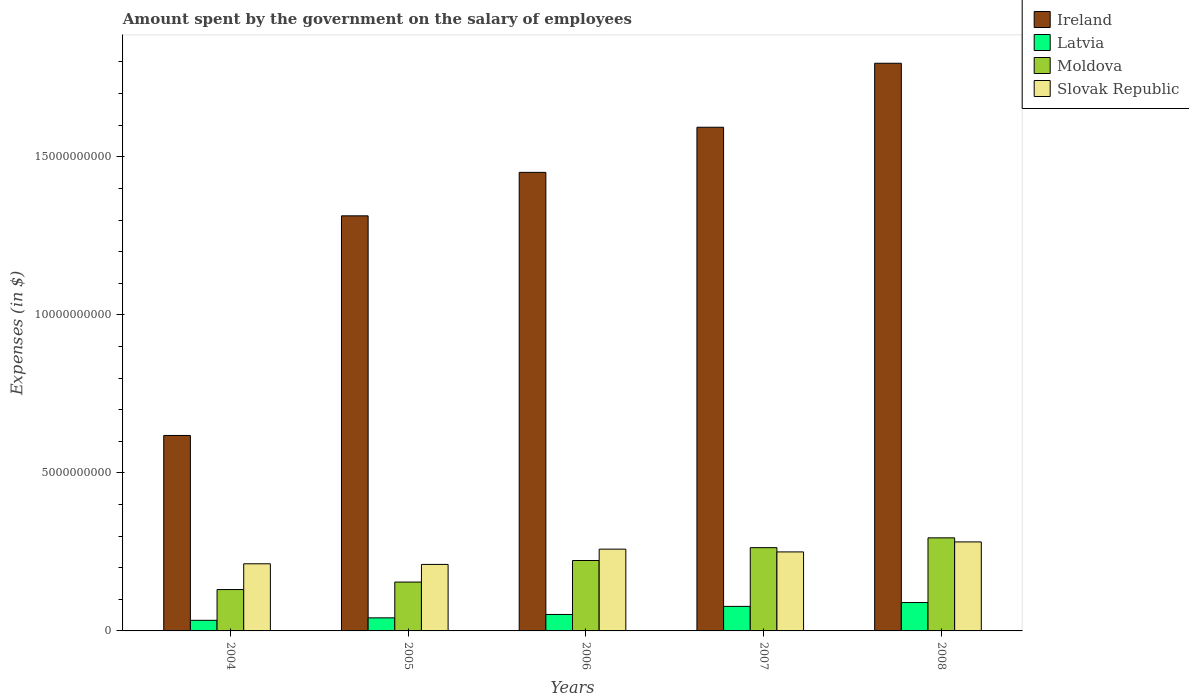How many different coloured bars are there?
Offer a very short reply. 4. How many groups of bars are there?
Your answer should be compact. 5. Are the number of bars per tick equal to the number of legend labels?
Ensure brevity in your answer.  Yes. How many bars are there on the 5th tick from the right?
Your response must be concise. 4. What is the amount spent on the salary of employees by the government in Slovak Republic in 2005?
Ensure brevity in your answer.  2.10e+09. Across all years, what is the maximum amount spent on the salary of employees by the government in Moldova?
Keep it short and to the point. 2.94e+09. Across all years, what is the minimum amount spent on the salary of employees by the government in Ireland?
Offer a terse response. 6.18e+09. In which year was the amount spent on the salary of employees by the government in Slovak Republic maximum?
Give a very brief answer. 2008. What is the total amount spent on the salary of employees by the government in Moldova in the graph?
Your answer should be very brief. 1.07e+1. What is the difference between the amount spent on the salary of employees by the government in Latvia in 2004 and that in 2008?
Ensure brevity in your answer.  -5.63e+08. What is the difference between the amount spent on the salary of employees by the government in Ireland in 2005 and the amount spent on the salary of employees by the government in Slovak Republic in 2006?
Make the answer very short. 1.05e+1. What is the average amount spent on the salary of employees by the government in Latvia per year?
Provide a short and direct response. 5.89e+08. In the year 2006, what is the difference between the amount spent on the salary of employees by the government in Latvia and amount spent on the salary of employees by the government in Ireland?
Offer a terse response. -1.40e+1. What is the ratio of the amount spent on the salary of employees by the government in Latvia in 2005 to that in 2007?
Make the answer very short. 0.53. Is the amount spent on the salary of employees by the government in Moldova in 2005 less than that in 2006?
Keep it short and to the point. Yes. Is the difference between the amount spent on the salary of employees by the government in Latvia in 2005 and 2007 greater than the difference between the amount spent on the salary of employees by the government in Ireland in 2005 and 2007?
Keep it short and to the point. Yes. What is the difference between the highest and the second highest amount spent on the salary of employees by the government in Ireland?
Give a very brief answer. 2.02e+09. What is the difference between the highest and the lowest amount spent on the salary of employees by the government in Slovak Republic?
Your answer should be compact. 7.11e+08. Is the sum of the amount spent on the salary of employees by the government in Slovak Republic in 2004 and 2005 greater than the maximum amount spent on the salary of employees by the government in Ireland across all years?
Provide a short and direct response. No. Is it the case that in every year, the sum of the amount spent on the salary of employees by the government in Latvia and amount spent on the salary of employees by the government in Moldova is greater than the sum of amount spent on the salary of employees by the government in Slovak Republic and amount spent on the salary of employees by the government in Ireland?
Provide a succinct answer. No. What does the 4th bar from the left in 2007 represents?
Ensure brevity in your answer.  Slovak Republic. What does the 1st bar from the right in 2004 represents?
Make the answer very short. Slovak Republic. Are all the bars in the graph horizontal?
Keep it short and to the point. No. Are the values on the major ticks of Y-axis written in scientific E-notation?
Provide a short and direct response. No. Does the graph contain grids?
Offer a very short reply. No. How many legend labels are there?
Offer a terse response. 4. What is the title of the graph?
Make the answer very short. Amount spent by the government on the salary of employees. What is the label or title of the Y-axis?
Provide a succinct answer. Expenses (in $). What is the Expenses (in $) in Ireland in 2004?
Provide a succinct answer. 6.18e+09. What is the Expenses (in $) in Latvia in 2004?
Make the answer very short. 3.35e+08. What is the Expenses (in $) in Moldova in 2004?
Ensure brevity in your answer.  1.31e+09. What is the Expenses (in $) in Slovak Republic in 2004?
Offer a very short reply. 2.12e+09. What is the Expenses (in $) of Ireland in 2005?
Your answer should be very brief. 1.31e+1. What is the Expenses (in $) in Latvia in 2005?
Offer a very short reply. 4.13e+08. What is the Expenses (in $) in Moldova in 2005?
Provide a short and direct response. 1.55e+09. What is the Expenses (in $) in Slovak Republic in 2005?
Provide a short and direct response. 2.10e+09. What is the Expenses (in $) in Ireland in 2006?
Offer a very short reply. 1.45e+1. What is the Expenses (in $) of Latvia in 2006?
Give a very brief answer. 5.21e+08. What is the Expenses (in $) of Moldova in 2006?
Your response must be concise. 2.23e+09. What is the Expenses (in $) of Slovak Republic in 2006?
Provide a short and direct response. 2.59e+09. What is the Expenses (in $) in Ireland in 2007?
Offer a terse response. 1.59e+1. What is the Expenses (in $) in Latvia in 2007?
Your response must be concise. 7.76e+08. What is the Expenses (in $) in Moldova in 2007?
Offer a terse response. 2.63e+09. What is the Expenses (in $) in Slovak Republic in 2007?
Keep it short and to the point. 2.50e+09. What is the Expenses (in $) in Ireland in 2008?
Ensure brevity in your answer.  1.80e+1. What is the Expenses (in $) in Latvia in 2008?
Offer a very short reply. 8.98e+08. What is the Expenses (in $) of Moldova in 2008?
Keep it short and to the point. 2.94e+09. What is the Expenses (in $) in Slovak Republic in 2008?
Your answer should be very brief. 2.82e+09. Across all years, what is the maximum Expenses (in $) in Ireland?
Your answer should be very brief. 1.80e+1. Across all years, what is the maximum Expenses (in $) in Latvia?
Your answer should be very brief. 8.98e+08. Across all years, what is the maximum Expenses (in $) of Moldova?
Offer a very short reply. 2.94e+09. Across all years, what is the maximum Expenses (in $) in Slovak Republic?
Your answer should be compact. 2.82e+09. Across all years, what is the minimum Expenses (in $) of Ireland?
Offer a very short reply. 6.18e+09. Across all years, what is the minimum Expenses (in $) in Latvia?
Ensure brevity in your answer.  3.35e+08. Across all years, what is the minimum Expenses (in $) in Moldova?
Give a very brief answer. 1.31e+09. Across all years, what is the minimum Expenses (in $) of Slovak Republic?
Keep it short and to the point. 2.10e+09. What is the total Expenses (in $) in Ireland in the graph?
Offer a very short reply. 6.77e+1. What is the total Expenses (in $) in Latvia in the graph?
Your response must be concise. 2.94e+09. What is the total Expenses (in $) of Moldova in the graph?
Offer a very short reply. 1.07e+1. What is the total Expenses (in $) of Slovak Republic in the graph?
Offer a terse response. 1.21e+1. What is the difference between the Expenses (in $) of Ireland in 2004 and that in 2005?
Offer a terse response. -6.95e+09. What is the difference between the Expenses (in $) in Latvia in 2004 and that in 2005?
Offer a very short reply. -7.79e+07. What is the difference between the Expenses (in $) of Moldova in 2004 and that in 2005?
Make the answer very short. -2.37e+08. What is the difference between the Expenses (in $) in Slovak Republic in 2004 and that in 2005?
Ensure brevity in your answer.  1.95e+07. What is the difference between the Expenses (in $) of Ireland in 2004 and that in 2006?
Provide a succinct answer. -8.32e+09. What is the difference between the Expenses (in $) in Latvia in 2004 and that in 2006?
Provide a short and direct response. -1.86e+08. What is the difference between the Expenses (in $) of Moldova in 2004 and that in 2006?
Keep it short and to the point. -9.19e+08. What is the difference between the Expenses (in $) of Slovak Republic in 2004 and that in 2006?
Ensure brevity in your answer.  -4.64e+08. What is the difference between the Expenses (in $) in Ireland in 2004 and that in 2007?
Offer a terse response. -9.75e+09. What is the difference between the Expenses (in $) of Latvia in 2004 and that in 2007?
Provide a succinct answer. -4.41e+08. What is the difference between the Expenses (in $) in Moldova in 2004 and that in 2007?
Make the answer very short. -1.33e+09. What is the difference between the Expenses (in $) of Slovak Republic in 2004 and that in 2007?
Make the answer very short. -3.76e+08. What is the difference between the Expenses (in $) of Ireland in 2004 and that in 2008?
Keep it short and to the point. -1.18e+1. What is the difference between the Expenses (in $) in Latvia in 2004 and that in 2008?
Offer a terse response. -5.63e+08. What is the difference between the Expenses (in $) in Moldova in 2004 and that in 2008?
Make the answer very short. -1.64e+09. What is the difference between the Expenses (in $) of Slovak Republic in 2004 and that in 2008?
Give a very brief answer. -6.92e+08. What is the difference between the Expenses (in $) in Ireland in 2005 and that in 2006?
Provide a short and direct response. -1.38e+09. What is the difference between the Expenses (in $) of Latvia in 2005 and that in 2006?
Your answer should be compact. -1.08e+08. What is the difference between the Expenses (in $) of Moldova in 2005 and that in 2006?
Your response must be concise. -6.82e+08. What is the difference between the Expenses (in $) in Slovak Republic in 2005 and that in 2006?
Ensure brevity in your answer.  -4.83e+08. What is the difference between the Expenses (in $) in Ireland in 2005 and that in 2007?
Your response must be concise. -2.80e+09. What is the difference between the Expenses (in $) in Latvia in 2005 and that in 2007?
Make the answer very short. -3.63e+08. What is the difference between the Expenses (in $) in Moldova in 2005 and that in 2007?
Offer a terse response. -1.09e+09. What is the difference between the Expenses (in $) of Slovak Republic in 2005 and that in 2007?
Give a very brief answer. -3.95e+08. What is the difference between the Expenses (in $) in Ireland in 2005 and that in 2008?
Provide a short and direct response. -4.83e+09. What is the difference between the Expenses (in $) of Latvia in 2005 and that in 2008?
Your answer should be compact. -4.85e+08. What is the difference between the Expenses (in $) in Moldova in 2005 and that in 2008?
Your answer should be compact. -1.40e+09. What is the difference between the Expenses (in $) of Slovak Republic in 2005 and that in 2008?
Your response must be concise. -7.11e+08. What is the difference between the Expenses (in $) in Ireland in 2006 and that in 2007?
Your answer should be very brief. -1.43e+09. What is the difference between the Expenses (in $) in Latvia in 2006 and that in 2007?
Give a very brief answer. -2.56e+08. What is the difference between the Expenses (in $) of Moldova in 2006 and that in 2007?
Your response must be concise. -4.07e+08. What is the difference between the Expenses (in $) in Slovak Republic in 2006 and that in 2007?
Your response must be concise. 8.77e+07. What is the difference between the Expenses (in $) in Ireland in 2006 and that in 2008?
Provide a succinct answer. -3.45e+09. What is the difference between the Expenses (in $) of Latvia in 2006 and that in 2008?
Your response must be concise. -3.77e+08. What is the difference between the Expenses (in $) of Moldova in 2006 and that in 2008?
Keep it short and to the point. -7.17e+08. What is the difference between the Expenses (in $) of Slovak Republic in 2006 and that in 2008?
Provide a short and direct response. -2.28e+08. What is the difference between the Expenses (in $) in Ireland in 2007 and that in 2008?
Keep it short and to the point. -2.02e+09. What is the difference between the Expenses (in $) in Latvia in 2007 and that in 2008?
Offer a terse response. -1.22e+08. What is the difference between the Expenses (in $) in Moldova in 2007 and that in 2008?
Your answer should be compact. -3.10e+08. What is the difference between the Expenses (in $) in Slovak Republic in 2007 and that in 2008?
Provide a short and direct response. -3.16e+08. What is the difference between the Expenses (in $) of Ireland in 2004 and the Expenses (in $) of Latvia in 2005?
Keep it short and to the point. 5.77e+09. What is the difference between the Expenses (in $) in Ireland in 2004 and the Expenses (in $) in Moldova in 2005?
Your response must be concise. 4.64e+09. What is the difference between the Expenses (in $) of Ireland in 2004 and the Expenses (in $) of Slovak Republic in 2005?
Offer a terse response. 4.08e+09. What is the difference between the Expenses (in $) in Latvia in 2004 and the Expenses (in $) in Moldova in 2005?
Ensure brevity in your answer.  -1.21e+09. What is the difference between the Expenses (in $) of Latvia in 2004 and the Expenses (in $) of Slovak Republic in 2005?
Ensure brevity in your answer.  -1.77e+09. What is the difference between the Expenses (in $) of Moldova in 2004 and the Expenses (in $) of Slovak Republic in 2005?
Make the answer very short. -7.95e+08. What is the difference between the Expenses (in $) of Ireland in 2004 and the Expenses (in $) of Latvia in 2006?
Ensure brevity in your answer.  5.66e+09. What is the difference between the Expenses (in $) of Ireland in 2004 and the Expenses (in $) of Moldova in 2006?
Your answer should be compact. 3.96e+09. What is the difference between the Expenses (in $) of Ireland in 2004 and the Expenses (in $) of Slovak Republic in 2006?
Your response must be concise. 3.60e+09. What is the difference between the Expenses (in $) of Latvia in 2004 and the Expenses (in $) of Moldova in 2006?
Offer a very short reply. -1.89e+09. What is the difference between the Expenses (in $) in Latvia in 2004 and the Expenses (in $) in Slovak Republic in 2006?
Provide a short and direct response. -2.25e+09. What is the difference between the Expenses (in $) of Moldova in 2004 and the Expenses (in $) of Slovak Republic in 2006?
Give a very brief answer. -1.28e+09. What is the difference between the Expenses (in $) in Ireland in 2004 and the Expenses (in $) in Latvia in 2007?
Offer a terse response. 5.41e+09. What is the difference between the Expenses (in $) in Ireland in 2004 and the Expenses (in $) in Moldova in 2007?
Offer a terse response. 3.55e+09. What is the difference between the Expenses (in $) in Ireland in 2004 and the Expenses (in $) in Slovak Republic in 2007?
Offer a terse response. 3.68e+09. What is the difference between the Expenses (in $) of Latvia in 2004 and the Expenses (in $) of Moldova in 2007?
Provide a succinct answer. -2.30e+09. What is the difference between the Expenses (in $) of Latvia in 2004 and the Expenses (in $) of Slovak Republic in 2007?
Your response must be concise. -2.16e+09. What is the difference between the Expenses (in $) of Moldova in 2004 and the Expenses (in $) of Slovak Republic in 2007?
Give a very brief answer. -1.19e+09. What is the difference between the Expenses (in $) in Ireland in 2004 and the Expenses (in $) in Latvia in 2008?
Provide a short and direct response. 5.29e+09. What is the difference between the Expenses (in $) of Ireland in 2004 and the Expenses (in $) of Moldova in 2008?
Give a very brief answer. 3.24e+09. What is the difference between the Expenses (in $) in Ireland in 2004 and the Expenses (in $) in Slovak Republic in 2008?
Your response must be concise. 3.37e+09. What is the difference between the Expenses (in $) of Latvia in 2004 and the Expenses (in $) of Moldova in 2008?
Provide a short and direct response. -2.61e+09. What is the difference between the Expenses (in $) of Latvia in 2004 and the Expenses (in $) of Slovak Republic in 2008?
Give a very brief answer. -2.48e+09. What is the difference between the Expenses (in $) of Moldova in 2004 and the Expenses (in $) of Slovak Republic in 2008?
Ensure brevity in your answer.  -1.51e+09. What is the difference between the Expenses (in $) of Ireland in 2005 and the Expenses (in $) of Latvia in 2006?
Your answer should be very brief. 1.26e+1. What is the difference between the Expenses (in $) in Ireland in 2005 and the Expenses (in $) in Moldova in 2006?
Offer a terse response. 1.09e+1. What is the difference between the Expenses (in $) in Ireland in 2005 and the Expenses (in $) in Slovak Republic in 2006?
Ensure brevity in your answer.  1.05e+1. What is the difference between the Expenses (in $) in Latvia in 2005 and the Expenses (in $) in Moldova in 2006?
Ensure brevity in your answer.  -1.81e+09. What is the difference between the Expenses (in $) of Latvia in 2005 and the Expenses (in $) of Slovak Republic in 2006?
Your answer should be very brief. -2.17e+09. What is the difference between the Expenses (in $) in Moldova in 2005 and the Expenses (in $) in Slovak Republic in 2006?
Ensure brevity in your answer.  -1.04e+09. What is the difference between the Expenses (in $) in Ireland in 2005 and the Expenses (in $) in Latvia in 2007?
Your answer should be very brief. 1.24e+1. What is the difference between the Expenses (in $) of Ireland in 2005 and the Expenses (in $) of Moldova in 2007?
Your answer should be very brief. 1.05e+1. What is the difference between the Expenses (in $) in Ireland in 2005 and the Expenses (in $) in Slovak Republic in 2007?
Ensure brevity in your answer.  1.06e+1. What is the difference between the Expenses (in $) in Latvia in 2005 and the Expenses (in $) in Moldova in 2007?
Make the answer very short. -2.22e+09. What is the difference between the Expenses (in $) of Latvia in 2005 and the Expenses (in $) of Slovak Republic in 2007?
Your answer should be compact. -2.09e+09. What is the difference between the Expenses (in $) in Moldova in 2005 and the Expenses (in $) in Slovak Republic in 2007?
Ensure brevity in your answer.  -9.54e+08. What is the difference between the Expenses (in $) of Ireland in 2005 and the Expenses (in $) of Latvia in 2008?
Your answer should be compact. 1.22e+1. What is the difference between the Expenses (in $) of Ireland in 2005 and the Expenses (in $) of Moldova in 2008?
Offer a very short reply. 1.02e+1. What is the difference between the Expenses (in $) of Ireland in 2005 and the Expenses (in $) of Slovak Republic in 2008?
Keep it short and to the point. 1.03e+1. What is the difference between the Expenses (in $) in Latvia in 2005 and the Expenses (in $) in Moldova in 2008?
Make the answer very short. -2.53e+09. What is the difference between the Expenses (in $) of Latvia in 2005 and the Expenses (in $) of Slovak Republic in 2008?
Your answer should be very brief. -2.40e+09. What is the difference between the Expenses (in $) of Moldova in 2005 and the Expenses (in $) of Slovak Republic in 2008?
Your answer should be compact. -1.27e+09. What is the difference between the Expenses (in $) in Ireland in 2006 and the Expenses (in $) in Latvia in 2007?
Your answer should be compact. 1.37e+1. What is the difference between the Expenses (in $) of Ireland in 2006 and the Expenses (in $) of Moldova in 2007?
Provide a succinct answer. 1.19e+1. What is the difference between the Expenses (in $) in Ireland in 2006 and the Expenses (in $) in Slovak Republic in 2007?
Offer a very short reply. 1.20e+1. What is the difference between the Expenses (in $) in Latvia in 2006 and the Expenses (in $) in Moldova in 2007?
Provide a succinct answer. -2.11e+09. What is the difference between the Expenses (in $) of Latvia in 2006 and the Expenses (in $) of Slovak Republic in 2007?
Ensure brevity in your answer.  -1.98e+09. What is the difference between the Expenses (in $) of Moldova in 2006 and the Expenses (in $) of Slovak Republic in 2007?
Provide a succinct answer. -2.72e+08. What is the difference between the Expenses (in $) of Ireland in 2006 and the Expenses (in $) of Latvia in 2008?
Your answer should be compact. 1.36e+1. What is the difference between the Expenses (in $) of Ireland in 2006 and the Expenses (in $) of Moldova in 2008?
Keep it short and to the point. 1.16e+1. What is the difference between the Expenses (in $) in Ireland in 2006 and the Expenses (in $) in Slovak Republic in 2008?
Ensure brevity in your answer.  1.17e+1. What is the difference between the Expenses (in $) in Latvia in 2006 and the Expenses (in $) in Moldova in 2008?
Your answer should be very brief. -2.42e+09. What is the difference between the Expenses (in $) in Latvia in 2006 and the Expenses (in $) in Slovak Republic in 2008?
Keep it short and to the point. -2.29e+09. What is the difference between the Expenses (in $) in Moldova in 2006 and the Expenses (in $) in Slovak Republic in 2008?
Keep it short and to the point. -5.88e+08. What is the difference between the Expenses (in $) of Ireland in 2007 and the Expenses (in $) of Latvia in 2008?
Give a very brief answer. 1.50e+1. What is the difference between the Expenses (in $) of Ireland in 2007 and the Expenses (in $) of Moldova in 2008?
Your answer should be very brief. 1.30e+1. What is the difference between the Expenses (in $) of Ireland in 2007 and the Expenses (in $) of Slovak Republic in 2008?
Provide a succinct answer. 1.31e+1. What is the difference between the Expenses (in $) in Latvia in 2007 and the Expenses (in $) in Moldova in 2008?
Make the answer very short. -2.17e+09. What is the difference between the Expenses (in $) of Latvia in 2007 and the Expenses (in $) of Slovak Republic in 2008?
Keep it short and to the point. -2.04e+09. What is the difference between the Expenses (in $) in Moldova in 2007 and the Expenses (in $) in Slovak Republic in 2008?
Provide a short and direct response. -1.81e+08. What is the average Expenses (in $) of Ireland per year?
Your answer should be very brief. 1.35e+1. What is the average Expenses (in $) in Latvia per year?
Make the answer very short. 5.89e+08. What is the average Expenses (in $) of Moldova per year?
Your answer should be very brief. 2.13e+09. What is the average Expenses (in $) in Slovak Republic per year?
Keep it short and to the point. 2.43e+09. In the year 2004, what is the difference between the Expenses (in $) of Ireland and Expenses (in $) of Latvia?
Offer a very short reply. 5.85e+09. In the year 2004, what is the difference between the Expenses (in $) of Ireland and Expenses (in $) of Moldova?
Keep it short and to the point. 4.88e+09. In the year 2004, what is the difference between the Expenses (in $) in Ireland and Expenses (in $) in Slovak Republic?
Your response must be concise. 4.06e+09. In the year 2004, what is the difference between the Expenses (in $) of Latvia and Expenses (in $) of Moldova?
Provide a succinct answer. -9.73e+08. In the year 2004, what is the difference between the Expenses (in $) in Latvia and Expenses (in $) in Slovak Republic?
Provide a short and direct response. -1.79e+09. In the year 2004, what is the difference between the Expenses (in $) in Moldova and Expenses (in $) in Slovak Republic?
Give a very brief answer. -8.15e+08. In the year 2005, what is the difference between the Expenses (in $) of Ireland and Expenses (in $) of Latvia?
Make the answer very short. 1.27e+1. In the year 2005, what is the difference between the Expenses (in $) of Ireland and Expenses (in $) of Moldova?
Your response must be concise. 1.16e+1. In the year 2005, what is the difference between the Expenses (in $) of Ireland and Expenses (in $) of Slovak Republic?
Provide a succinct answer. 1.10e+1. In the year 2005, what is the difference between the Expenses (in $) in Latvia and Expenses (in $) in Moldova?
Your response must be concise. -1.13e+09. In the year 2005, what is the difference between the Expenses (in $) in Latvia and Expenses (in $) in Slovak Republic?
Your answer should be very brief. -1.69e+09. In the year 2005, what is the difference between the Expenses (in $) in Moldova and Expenses (in $) in Slovak Republic?
Your answer should be very brief. -5.59e+08. In the year 2006, what is the difference between the Expenses (in $) of Ireland and Expenses (in $) of Latvia?
Your response must be concise. 1.40e+1. In the year 2006, what is the difference between the Expenses (in $) of Ireland and Expenses (in $) of Moldova?
Your response must be concise. 1.23e+1. In the year 2006, what is the difference between the Expenses (in $) in Ireland and Expenses (in $) in Slovak Republic?
Provide a succinct answer. 1.19e+1. In the year 2006, what is the difference between the Expenses (in $) in Latvia and Expenses (in $) in Moldova?
Your answer should be compact. -1.71e+09. In the year 2006, what is the difference between the Expenses (in $) in Latvia and Expenses (in $) in Slovak Republic?
Make the answer very short. -2.07e+09. In the year 2006, what is the difference between the Expenses (in $) in Moldova and Expenses (in $) in Slovak Republic?
Ensure brevity in your answer.  -3.60e+08. In the year 2007, what is the difference between the Expenses (in $) of Ireland and Expenses (in $) of Latvia?
Make the answer very short. 1.52e+1. In the year 2007, what is the difference between the Expenses (in $) of Ireland and Expenses (in $) of Moldova?
Give a very brief answer. 1.33e+1. In the year 2007, what is the difference between the Expenses (in $) of Ireland and Expenses (in $) of Slovak Republic?
Provide a short and direct response. 1.34e+1. In the year 2007, what is the difference between the Expenses (in $) of Latvia and Expenses (in $) of Moldova?
Give a very brief answer. -1.86e+09. In the year 2007, what is the difference between the Expenses (in $) of Latvia and Expenses (in $) of Slovak Republic?
Ensure brevity in your answer.  -1.72e+09. In the year 2007, what is the difference between the Expenses (in $) in Moldova and Expenses (in $) in Slovak Republic?
Keep it short and to the point. 1.35e+08. In the year 2008, what is the difference between the Expenses (in $) of Ireland and Expenses (in $) of Latvia?
Give a very brief answer. 1.71e+1. In the year 2008, what is the difference between the Expenses (in $) in Ireland and Expenses (in $) in Moldova?
Make the answer very short. 1.50e+1. In the year 2008, what is the difference between the Expenses (in $) in Ireland and Expenses (in $) in Slovak Republic?
Your response must be concise. 1.51e+1. In the year 2008, what is the difference between the Expenses (in $) of Latvia and Expenses (in $) of Moldova?
Offer a terse response. -2.05e+09. In the year 2008, what is the difference between the Expenses (in $) of Latvia and Expenses (in $) of Slovak Republic?
Your response must be concise. -1.92e+09. In the year 2008, what is the difference between the Expenses (in $) of Moldova and Expenses (in $) of Slovak Republic?
Your answer should be very brief. 1.29e+08. What is the ratio of the Expenses (in $) in Ireland in 2004 to that in 2005?
Your answer should be compact. 0.47. What is the ratio of the Expenses (in $) of Latvia in 2004 to that in 2005?
Your answer should be very brief. 0.81. What is the ratio of the Expenses (in $) in Moldova in 2004 to that in 2005?
Offer a very short reply. 0.85. What is the ratio of the Expenses (in $) of Slovak Republic in 2004 to that in 2005?
Make the answer very short. 1.01. What is the ratio of the Expenses (in $) of Ireland in 2004 to that in 2006?
Offer a very short reply. 0.43. What is the ratio of the Expenses (in $) in Latvia in 2004 to that in 2006?
Offer a terse response. 0.64. What is the ratio of the Expenses (in $) in Moldova in 2004 to that in 2006?
Provide a short and direct response. 0.59. What is the ratio of the Expenses (in $) in Slovak Republic in 2004 to that in 2006?
Your response must be concise. 0.82. What is the ratio of the Expenses (in $) of Ireland in 2004 to that in 2007?
Offer a terse response. 0.39. What is the ratio of the Expenses (in $) of Latvia in 2004 to that in 2007?
Your answer should be very brief. 0.43. What is the ratio of the Expenses (in $) of Moldova in 2004 to that in 2007?
Offer a terse response. 0.5. What is the ratio of the Expenses (in $) of Slovak Republic in 2004 to that in 2007?
Offer a very short reply. 0.85. What is the ratio of the Expenses (in $) of Ireland in 2004 to that in 2008?
Give a very brief answer. 0.34. What is the ratio of the Expenses (in $) of Latvia in 2004 to that in 2008?
Your answer should be compact. 0.37. What is the ratio of the Expenses (in $) in Moldova in 2004 to that in 2008?
Your answer should be very brief. 0.44. What is the ratio of the Expenses (in $) in Slovak Republic in 2004 to that in 2008?
Make the answer very short. 0.75. What is the ratio of the Expenses (in $) of Ireland in 2005 to that in 2006?
Your response must be concise. 0.91. What is the ratio of the Expenses (in $) of Latvia in 2005 to that in 2006?
Provide a short and direct response. 0.79. What is the ratio of the Expenses (in $) in Moldova in 2005 to that in 2006?
Your answer should be very brief. 0.69. What is the ratio of the Expenses (in $) in Slovak Republic in 2005 to that in 2006?
Ensure brevity in your answer.  0.81. What is the ratio of the Expenses (in $) in Ireland in 2005 to that in 2007?
Make the answer very short. 0.82. What is the ratio of the Expenses (in $) in Latvia in 2005 to that in 2007?
Keep it short and to the point. 0.53. What is the ratio of the Expenses (in $) of Moldova in 2005 to that in 2007?
Give a very brief answer. 0.59. What is the ratio of the Expenses (in $) of Slovak Republic in 2005 to that in 2007?
Keep it short and to the point. 0.84. What is the ratio of the Expenses (in $) of Ireland in 2005 to that in 2008?
Provide a short and direct response. 0.73. What is the ratio of the Expenses (in $) in Latvia in 2005 to that in 2008?
Your answer should be very brief. 0.46. What is the ratio of the Expenses (in $) of Moldova in 2005 to that in 2008?
Give a very brief answer. 0.52. What is the ratio of the Expenses (in $) in Slovak Republic in 2005 to that in 2008?
Keep it short and to the point. 0.75. What is the ratio of the Expenses (in $) in Ireland in 2006 to that in 2007?
Provide a short and direct response. 0.91. What is the ratio of the Expenses (in $) of Latvia in 2006 to that in 2007?
Offer a very short reply. 0.67. What is the ratio of the Expenses (in $) of Moldova in 2006 to that in 2007?
Provide a succinct answer. 0.85. What is the ratio of the Expenses (in $) in Slovak Republic in 2006 to that in 2007?
Keep it short and to the point. 1.04. What is the ratio of the Expenses (in $) in Ireland in 2006 to that in 2008?
Offer a terse response. 0.81. What is the ratio of the Expenses (in $) in Latvia in 2006 to that in 2008?
Keep it short and to the point. 0.58. What is the ratio of the Expenses (in $) of Moldova in 2006 to that in 2008?
Your answer should be very brief. 0.76. What is the ratio of the Expenses (in $) in Slovak Republic in 2006 to that in 2008?
Keep it short and to the point. 0.92. What is the ratio of the Expenses (in $) of Ireland in 2007 to that in 2008?
Provide a short and direct response. 0.89. What is the ratio of the Expenses (in $) in Latvia in 2007 to that in 2008?
Make the answer very short. 0.86. What is the ratio of the Expenses (in $) of Moldova in 2007 to that in 2008?
Give a very brief answer. 0.89. What is the ratio of the Expenses (in $) of Slovak Republic in 2007 to that in 2008?
Your response must be concise. 0.89. What is the difference between the highest and the second highest Expenses (in $) in Ireland?
Your response must be concise. 2.02e+09. What is the difference between the highest and the second highest Expenses (in $) of Latvia?
Make the answer very short. 1.22e+08. What is the difference between the highest and the second highest Expenses (in $) of Moldova?
Ensure brevity in your answer.  3.10e+08. What is the difference between the highest and the second highest Expenses (in $) in Slovak Republic?
Give a very brief answer. 2.28e+08. What is the difference between the highest and the lowest Expenses (in $) of Ireland?
Keep it short and to the point. 1.18e+1. What is the difference between the highest and the lowest Expenses (in $) in Latvia?
Give a very brief answer. 5.63e+08. What is the difference between the highest and the lowest Expenses (in $) of Moldova?
Give a very brief answer. 1.64e+09. What is the difference between the highest and the lowest Expenses (in $) of Slovak Republic?
Give a very brief answer. 7.11e+08. 